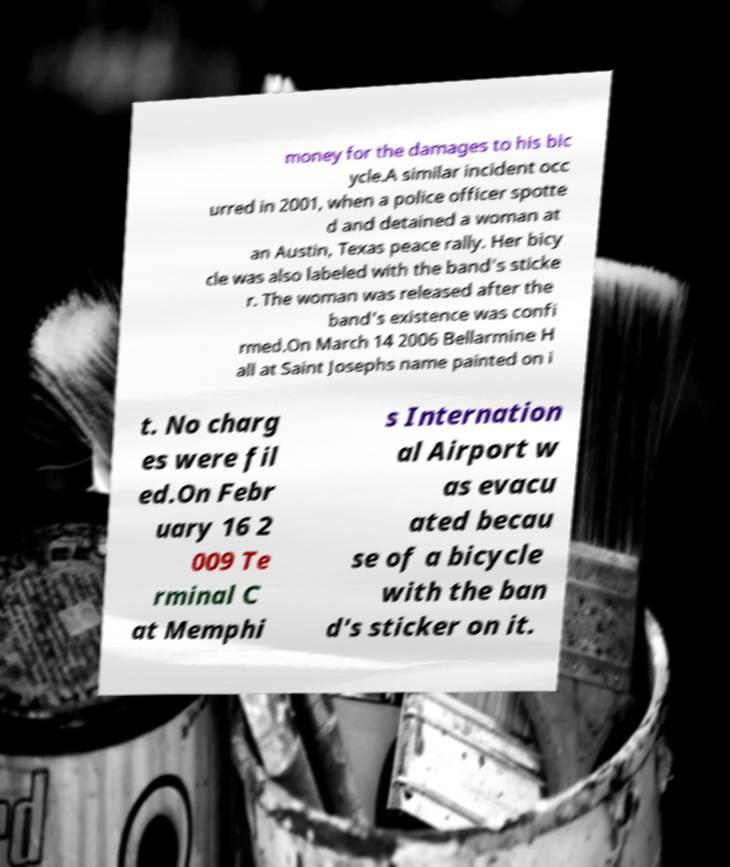I need the written content from this picture converted into text. Can you do that? money for the damages to his bic ycle.A similar incident occ urred in 2001, when a police officer spotte d and detained a woman at an Austin, Texas peace rally. Her bicy cle was also labeled with the band's sticke r. The woman was released after the band's existence was confi rmed.On March 14 2006 Bellarmine H all at Saint Josephs name painted on i t. No charg es were fil ed.On Febr uary 16 2 009 Te rminal C at Memphi s Internation al Airport w as evacu ated becau se of a bicycle with the ban d's sticker on it. 